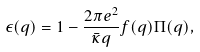Convert formula to latex. <formula><loc_0><loc_0><loc_500><loc_500>\epsilon ( q ) = 1 - \frac { 2 \pi e ^ { 2 } } { \bar { \kappa } q } f ( q ) \Pi ( q ) ,</formula> 